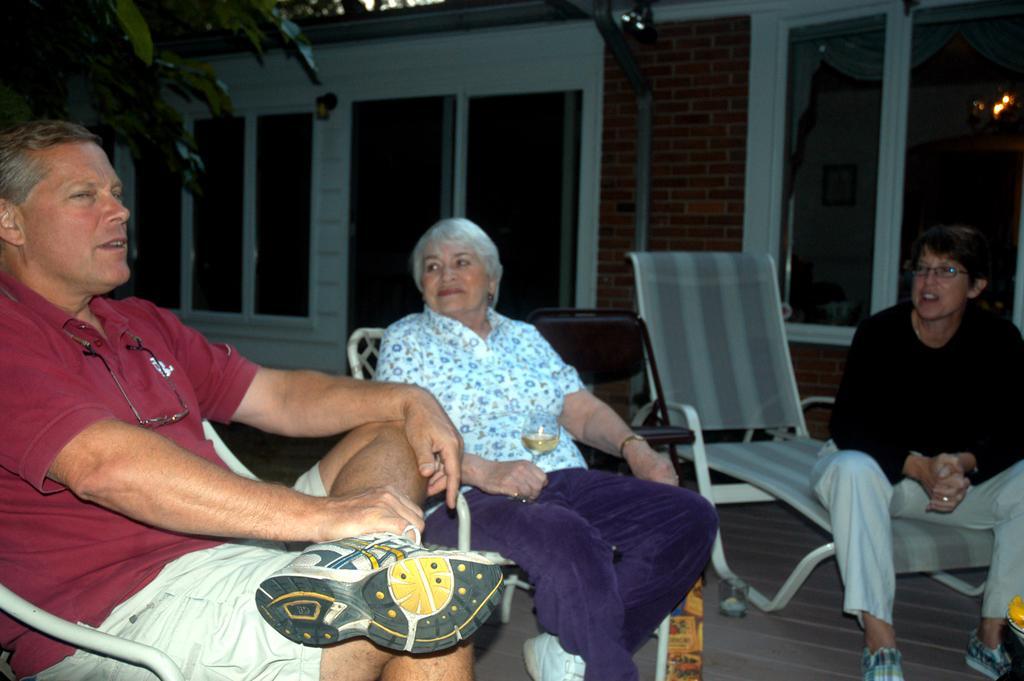Can you describe this image briefly? In this image I can see chairs, on which I can see three persons, visible in front of the building , and I can see a window, through window I can see lights on the right side , in the top left I can see leaves. 